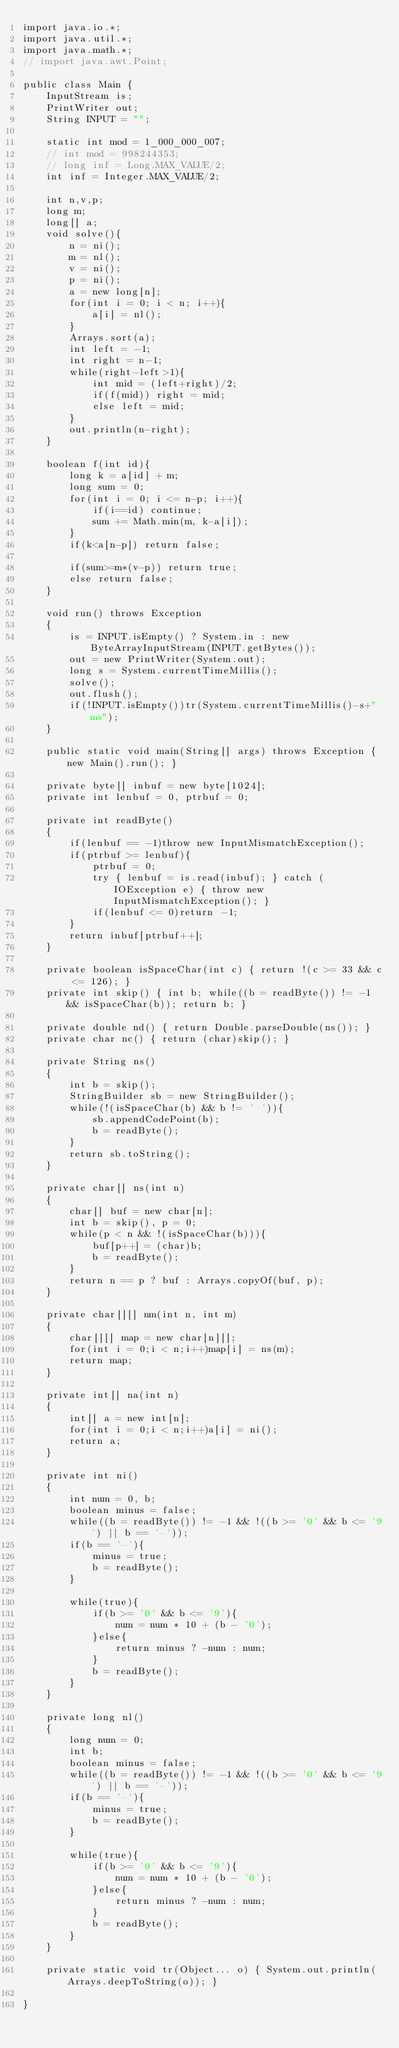Convert code to text. <code><loc_0><loc_0><loc_500><loc_500><_Java_>import java.io.*;
import java.util.*;
import java.math.*;
// import java.awt.Point;
 
public class Main {
    InputStream is;
    PrintWriter out;
    String INPUT = "";
 
    static int mod = 1_000_000_007;
    // int mod = 998244353;
    // long inf = Long.MAX_VALUE/2;
    int inf = Integer.MAX_VALUE/2;

    int n,v,p;
    long m;
    long[] a;
    void solve(){
        n = ni();
        m = nl();
        v = ni();
        p = ni();
        a = new long[n];
        for(int i = 0; i < n; i++){
            a[i] = nl();
        }
        Arrays.sort(a);
        int left = -1;
        int right = n-1;
        while(right-left>1){
            int mid = (left+right)/2;
            if(f(mid)) right = mid;
            else left = mid;
        }
        out.println(n-right);
    }

    boolean f(int id){
        long k = a[id] + m;
        long sum = 0;
        for(int i = 0; i <= n-p; i++){
            if(i==id) continue;
            sum += Math.min(m, k-a[i]);
        }
        if(k<a[n-p]) return false;
        
        if(sum>=m*(v-p)) return true;
        else return false;
    }

    void run() throws Exception
    {
        is = INPUT.isEmpty() ? System.in : new ByteArrayInputStream(INPUT.getBytes());
        out = new PrintWriter(System.out);
        long s = System.currentTimeMillis();
        solve();
        out.flush();
        if(!INPUT.isEmpty())tr(System.currentTimeMillis()-s+"ms");
    }
    
    public static void main(String[] args) throws Exception { new Main().run(); }
    
    private byte[] inbuf = new byte[1024];
    private int lenbuf = 0, ptrbuf = 0;
    
    private int readByte()
    {
        if(lenbuf == -1)throw new InputMismatchException();
        if(ptrbuf >= lenbuf){
            ptrbuf = 0;
            try { lenbuf = is.read(inbuf); } catch (IOException e) { throw new InputMismatchException(); }
            if(lenbuf <= 0)return -1;
        }
        return inbuf[ptrbuf++];
    }
    
    private boolean isSpaceChar(int c) { return !(c >= 33 && c <= 126); }
    private int skip() { int b; while((b = readByte()) != -1 && isSpaceChar(b)); return b; }
    
    private double nd() { return Double.parseDouble(ns()); }
    private char nc() { return (char)skip(); }
    
    private String ns()
    {
        int b = skip();
        StringBuilder sb = new StringBuilder();
        while(!(isSpaceChar(b) && b != ' ')){
            sb.appendCodePoint(b);
            b = readByte();
        }
        return sb.toString();
    }
    
    private char[] ns(int n)
    {
        char[] buf = new char[n];
        int b = skip(), p = 0;
        while(p < n && !(isSpaceChar(b))){
            buf[p++] = (char)b;
            b = readByte();
        }
        return n == p ? buf : Arrays.copyOf(buf, p);
    }
    
    private char[][] nm(int n, int m)
    {
        char[][] map = new char[n][];
        for(int i = 0;i < n;i++)map[i] = ns(m);
        return map;
    }
    
    private int[] na(int n)
    {
        int[] a = new int[n];
        for(int i = 0;i < n;i++)a[i] = ni();
        return a;
    }
    
    private int ni()
    {
        int num = 0, b;
        boolean minus = false;
        while((b = readByte()) != -1 && !((b >= '0' && b <= '9') || b == '-'));
        if(b == '-'){
            minus = true;
            b = readByte();
        }
        
        while(true){
            if(b >= '0' && b <= '9'){
                num = num * 10 + (b - '0');
            }else{
                return minus ? -num : num;
            }
            b = readByte();
        }
    }
    
    private long nl()
    {
        long num = 0;
        int b;
        boolean minus = false;
        while((b = readByte()) != -1 && !((b >= '0' && b <= '9') || b == '-'));
        if(b == '-'){
            minus = true;
            b = readByte();
        }
        
        while(true){
            if(b >= '0' && b <= '9'){
                num = num * 10 + (b - '0');
            }else{
                return minus ? -num : num;
            }
            b = readByte();
        }
    }
    
    private static void tr(Object... o) { System.out.println(Arrays.deepToString(o)); }
 
}
</code> 